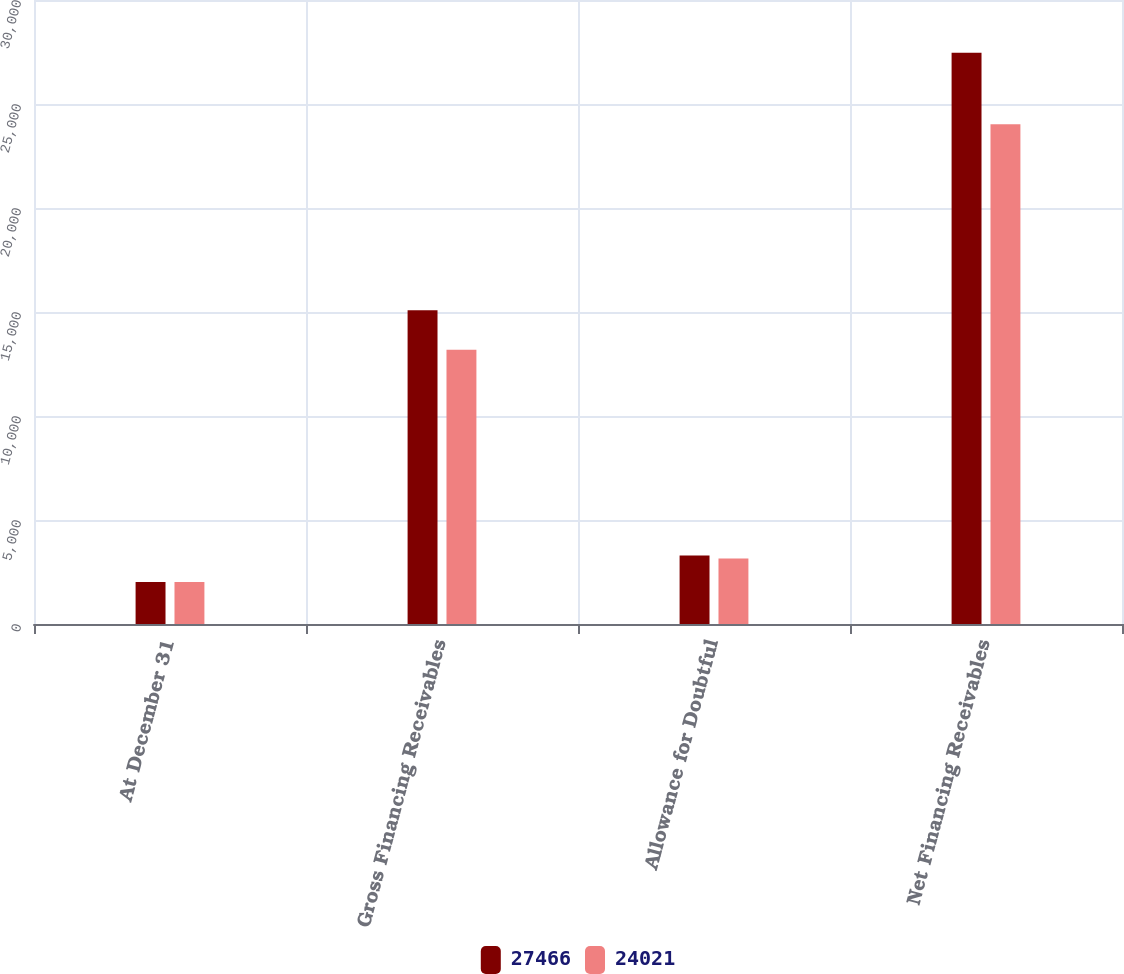Convert chart. <chart><loc_0><loc_0><loc_500><loc_500><stacked_bar_chart><ecel><fcel>At December 31<fcel>Gross Financing Receivables<fcel>Allowance for Doubtful<fcel>Net Financing Receivables<nl><fcel>27466<fcel>2015<fcel>15080<fcel>3288<fcel>27466<nl><fcel>24021<fcel>2014<fcel>13189<fcel>3150<fcel>24021<nl></chart> 